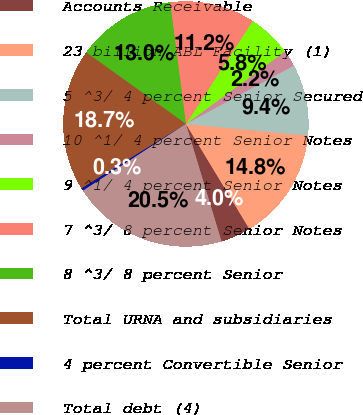<chart> <loc_0><loc_0><loc_500><loc_500><pie_chart><fcel>Accounts Receivable<fcel>23 billion ABL Facility (1)<fcel>5 ^3/ 4 percent Senior Secured<fcel>10 ^1/ 4 percent Senior Notes<fcel>9 ^1/ 4 percent Senior Notes<fcel>7 ^3/ 8 percent Senior Notes<fcel>8 ^3/ 8 percent Senior<fcel>Total URNA and subsidiaries<fcel>4 percent Convertible Senior<fcel>Total debt (4)<nl><fcel>3.97%<fcel>14.84%<fcel>9.41%<fcel>2.16%<fcel>5.78%<fcel>11.22%<fcel>13.03%<fcel>18.72%<fcel>0.35%<fcel>20.53%<nl></chart> 